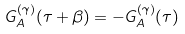<formula> <loc_0><loc_0><loc_500><loc_500>G _ { A } ^ { ( \gamma ) } ( \tau + \beta ) = - G _ { A } ^ { ( \gamma ) } ( \tau )</formula> 